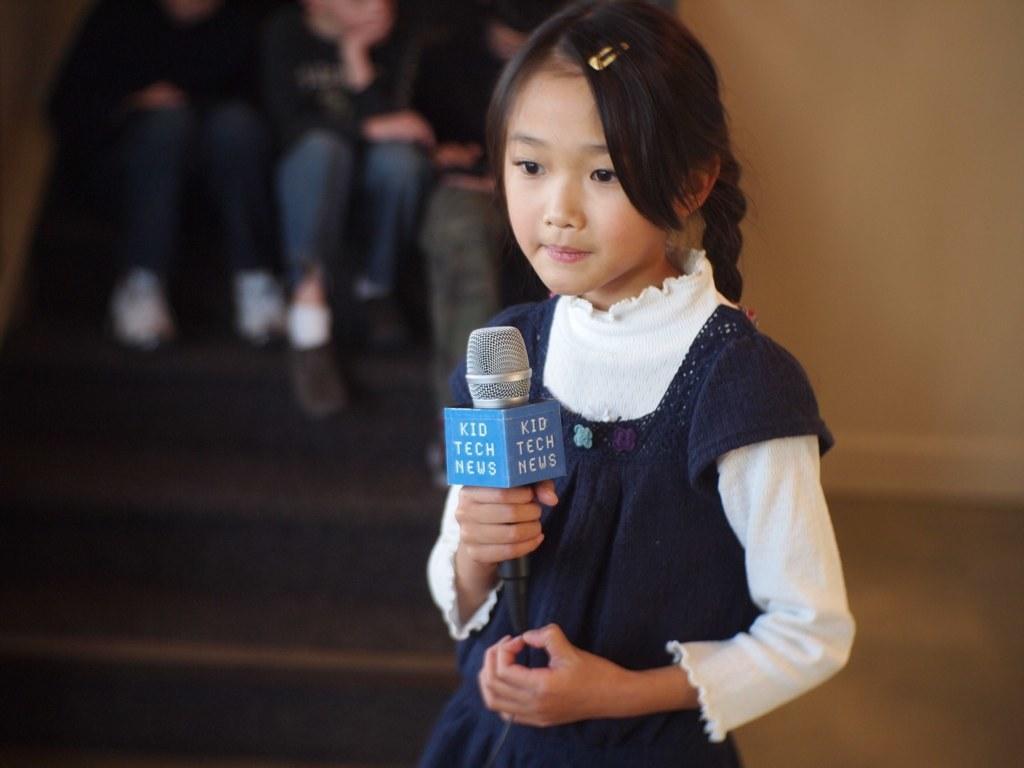Please provide a concise description of this image. This kid standing and holding microphone,behind this kid we can see wall,persons are sitting on the steps. 